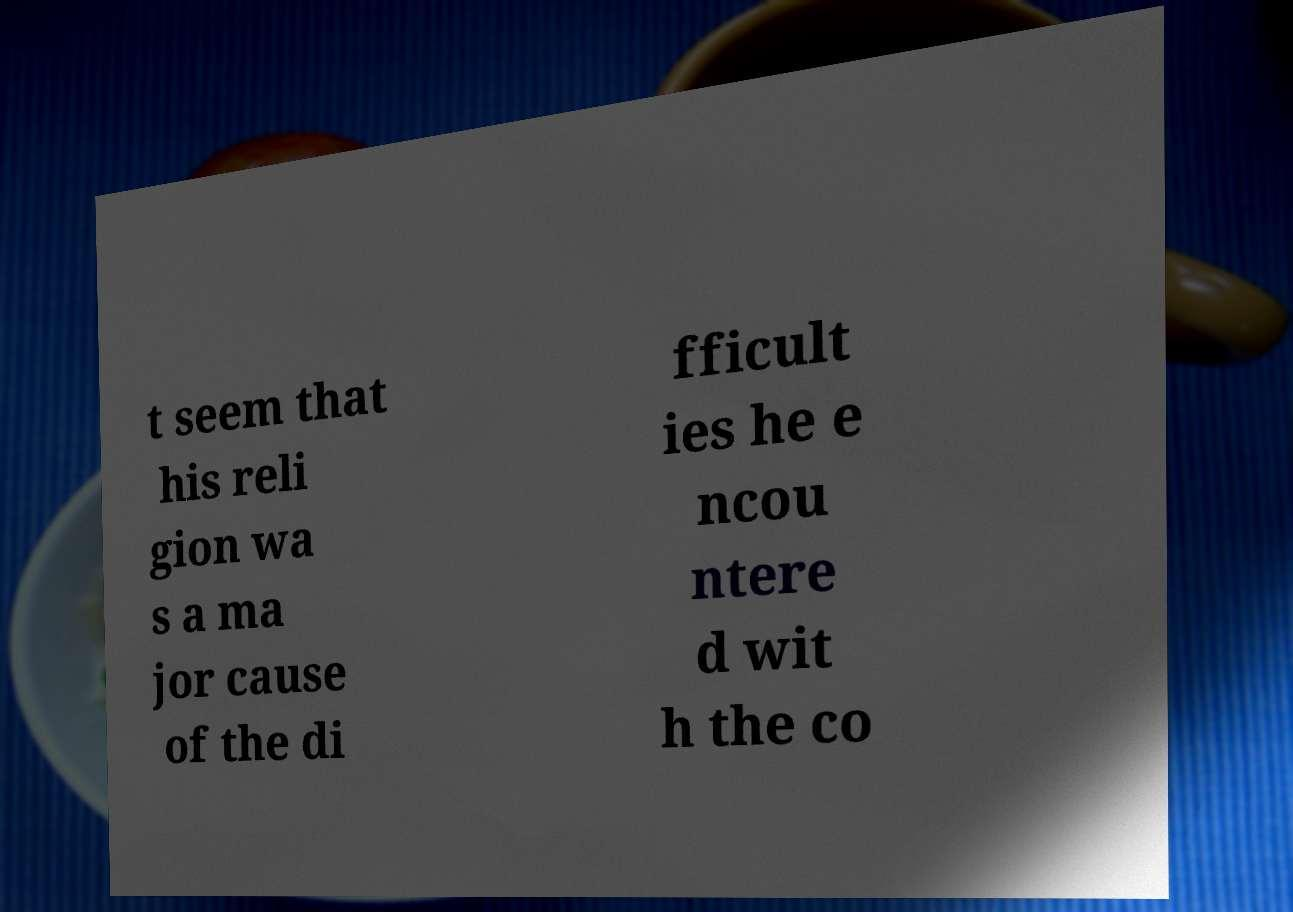What messages or text are displayed in this image? I need them in a readable, typed format. t seem that his reli gion wa s a ma jor cause of the di fficult ies he e ncou ntere d wit h the co 